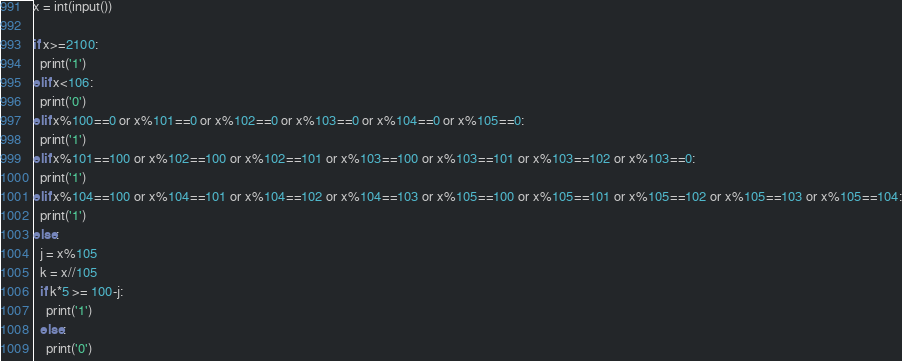Convert code to text. <code><loc_0><loc_0><loc_500><loc_500><_Python_>x = int(input())

if x>=2100:
  print('1')
elif x<106:
  print('0')
elif x%100==0 or x%101==0 or x%102==0 or x%103==0 or x%104==0 or x%105==0:
  print('1')
elif x%101==100 or x%102==100 or x%102==101 or x%103==100 or x%103==101 or x%103==102 or x%103==0:
  print('1')
elif x%104==100 or x%104==101 or x%104==102 or x%104==103 or x%105==100 or x%105==101 or x%105==102 or x%105==103 or x%105==104:
  print('1')
else:
  j = x%105
  k = x//105
  if k*5 >= 100-j:
    print('1')
  else:
    print('0')</code> 